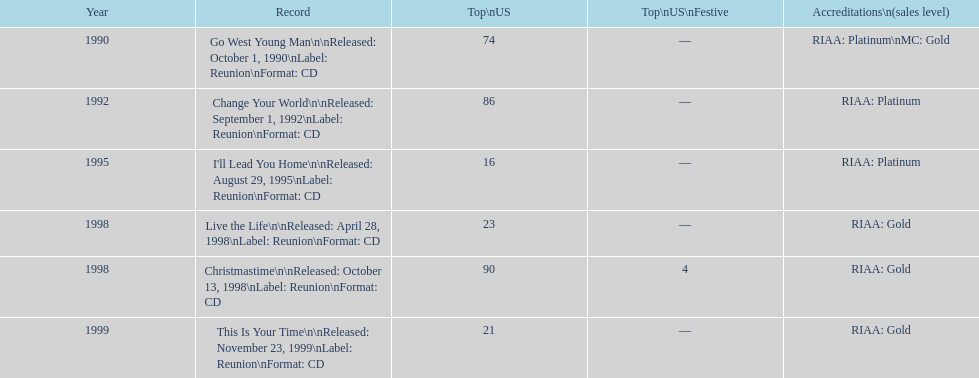Which album has the smallest peak in the us? I'll Lead You Home. 